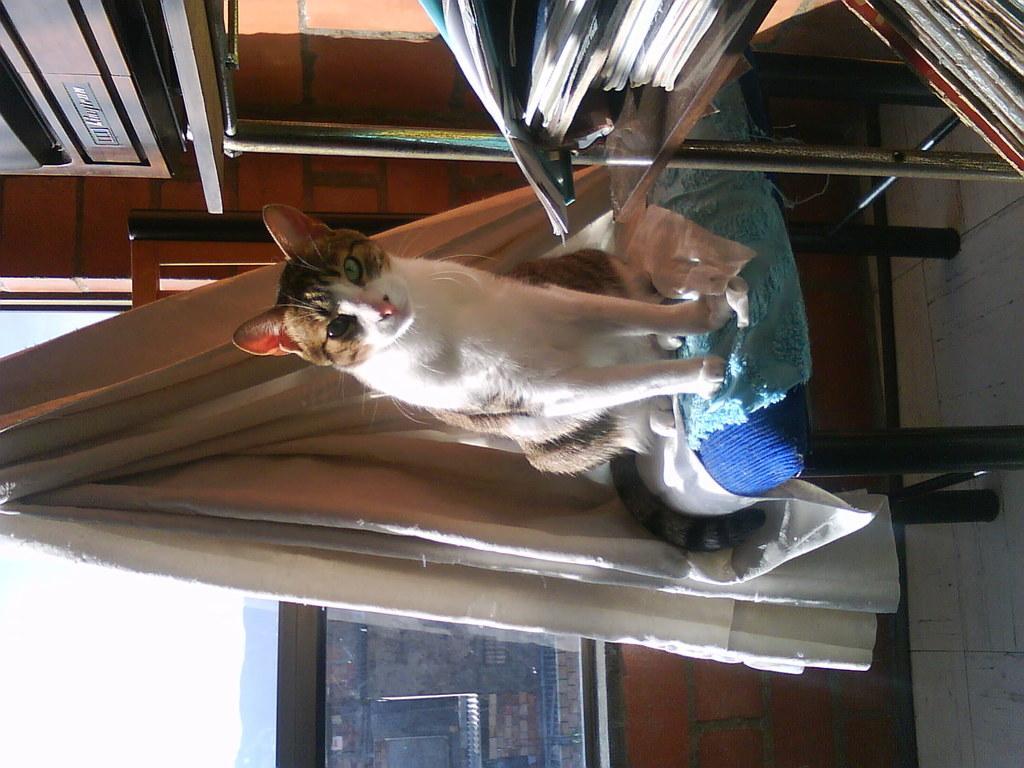How would you summarize this image in a sentence or two? In this image there is a cat on the stool having clothes. Top of the image there is a rack having books. There is an object on rack. Behind the cat there is a curtain. Background there is a wall having a window. From the window buildings and sky are visible. 